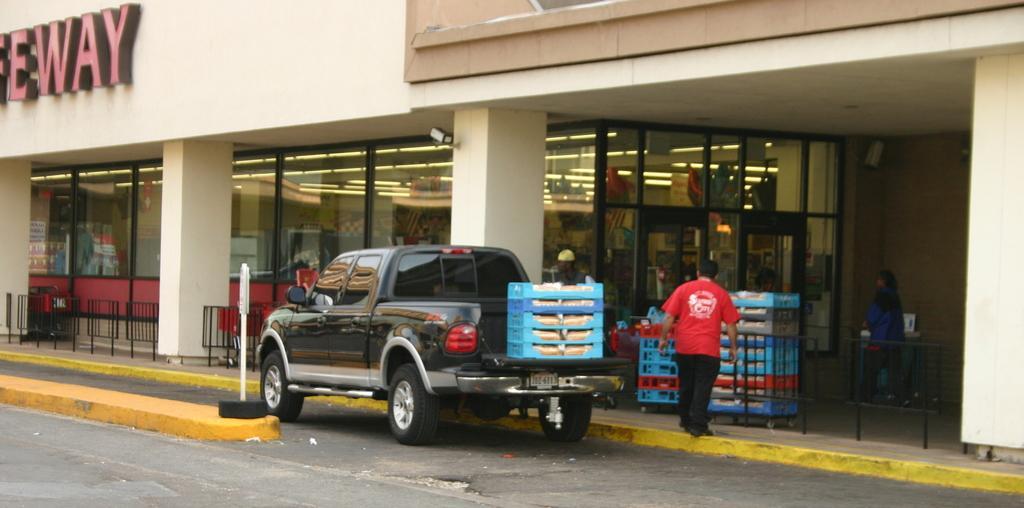In one or two sentences, can you explain what this image depicts? In this image there is a van on a road, in the background there is a shopping mall, in that there are boxes and glass windows. 